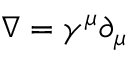Convert formula to latex. <formula><loc_0><loc_0><loc_500><loc_500>\nabla = \gamma ^ { \mu } \partial _ { \mu }</formula> 